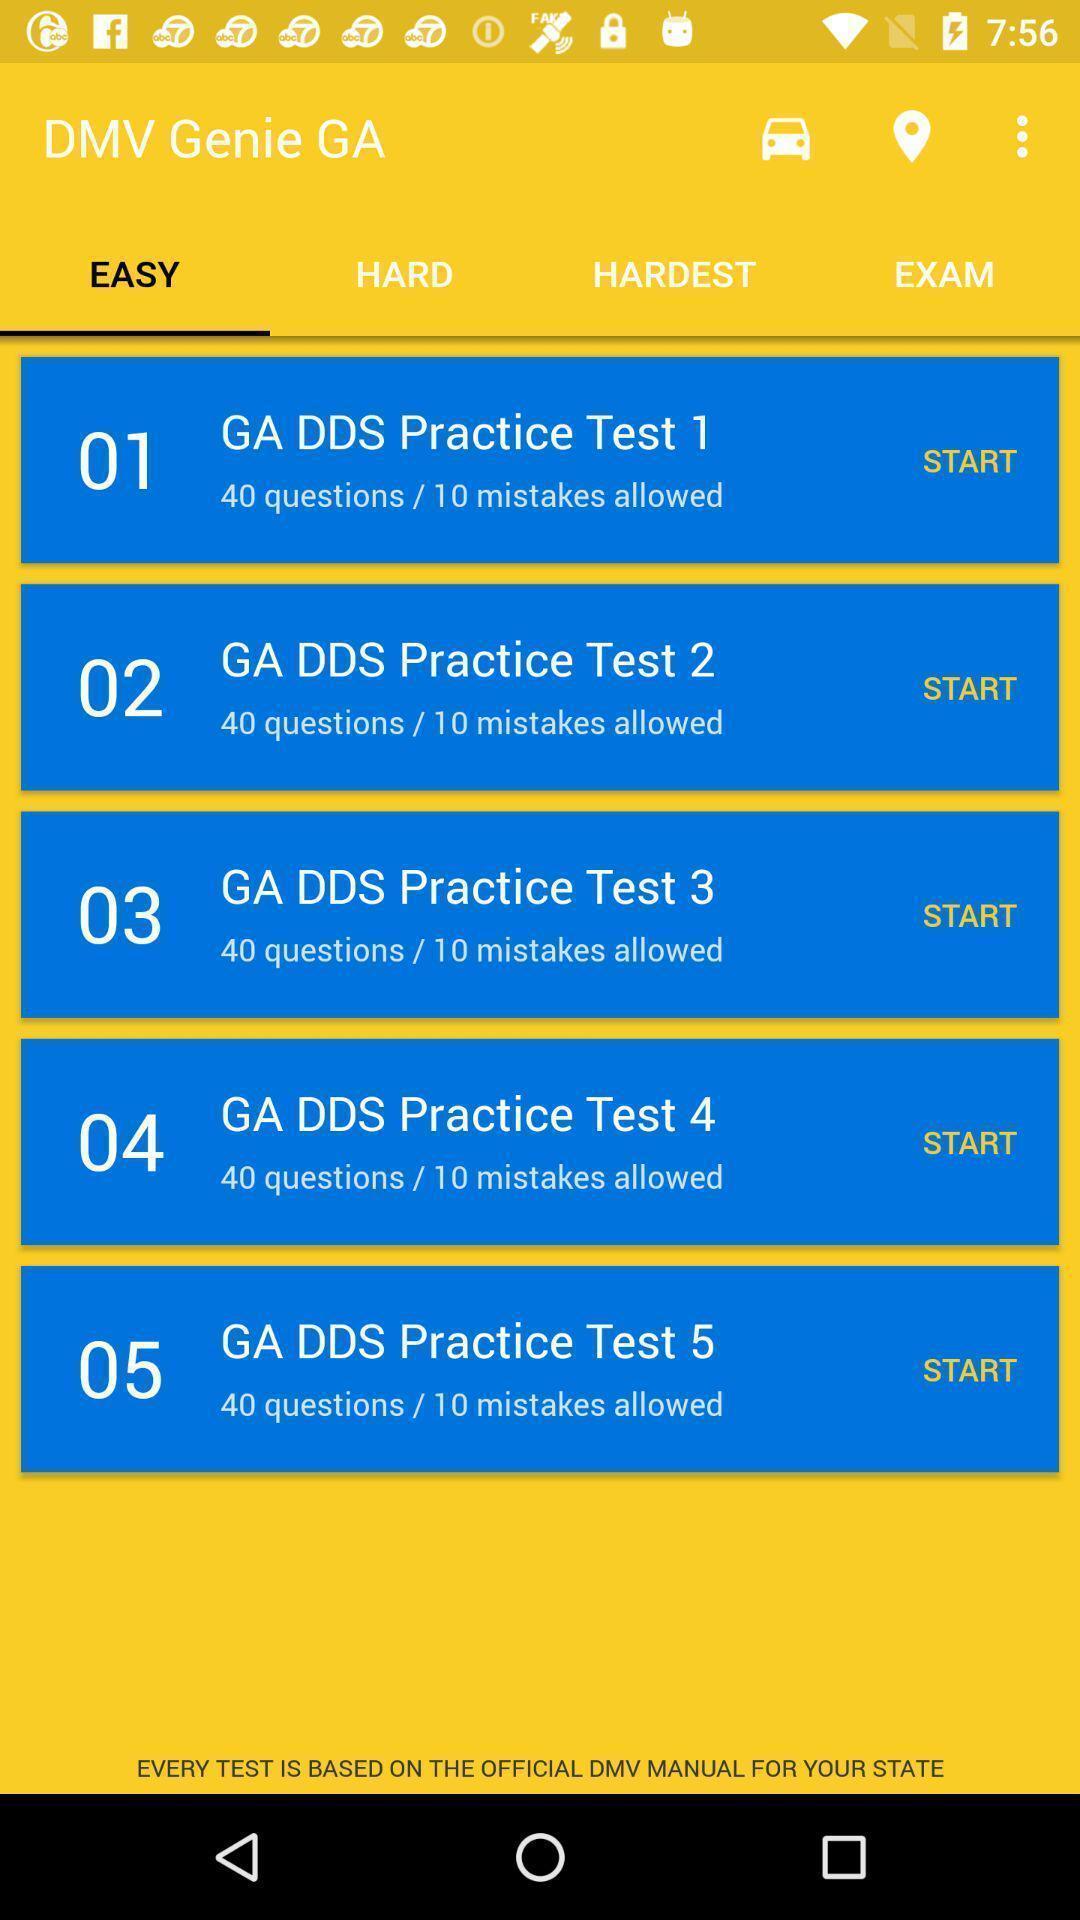What details can you identify in this image? Screen shows an easy genie app for practice sessions. 